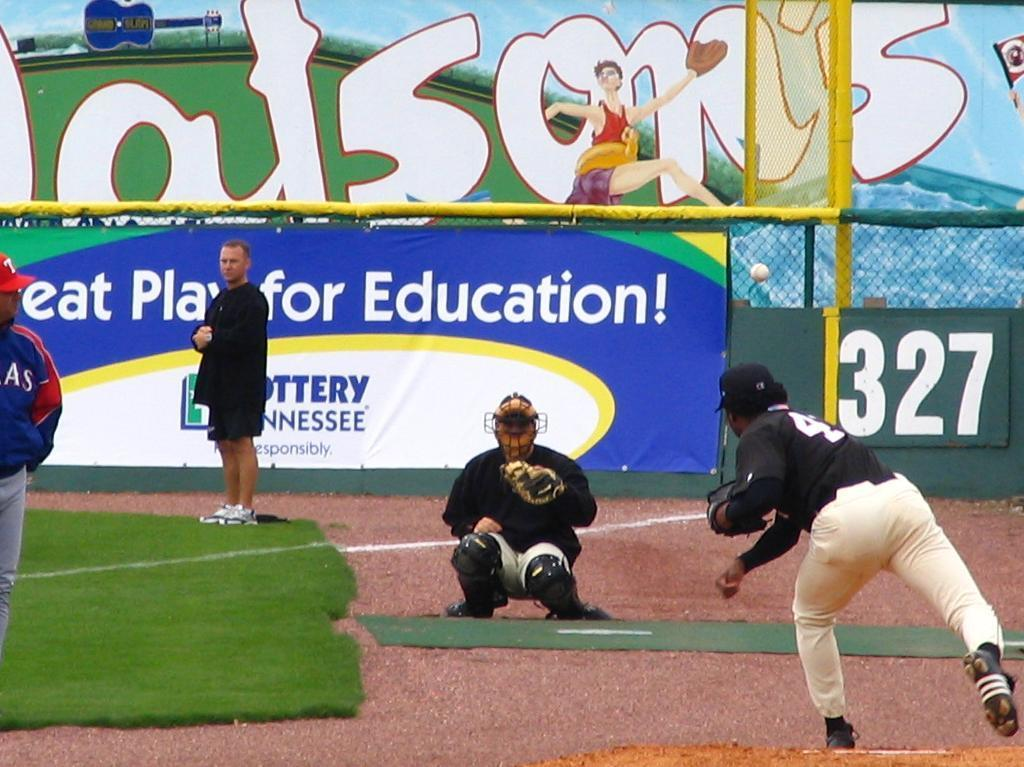Provide a one-sentence caption for the provided image. Baseball game happening in front of an ad that says "Great Play for Education!". 